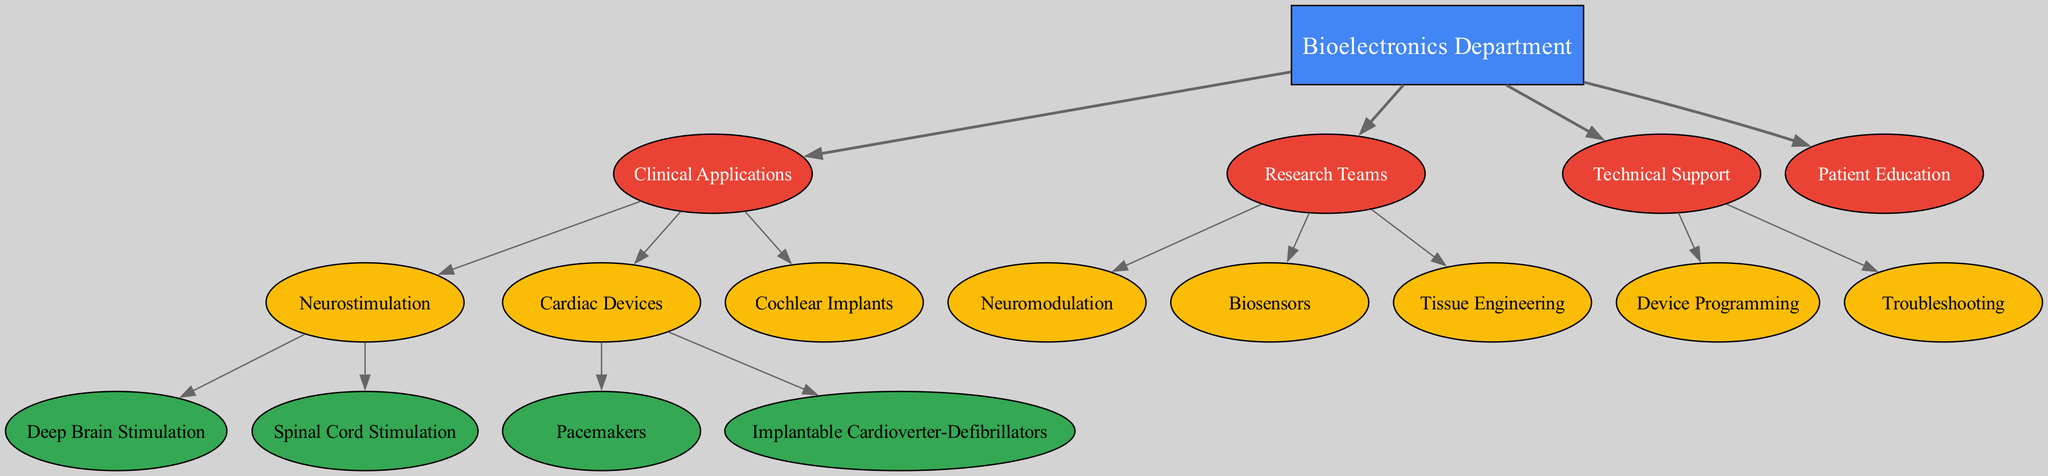What is the highest-level category in the diagram? The highest-level category in the diagram is "Bioelectronics Department," which encompasses all other specialties and teams within the structure. This can be identified as the root node of the hierarchy, indicating it is at the topmost position.
Answer: Bioelectronics Department How many main areas are there under the Bioelectronics Department? There are four main areas under the "Bioelectronics Department": Clinical Applications, Research Teams, Technical Support, and Patient Education. This can be determined by counting the first-level nodes branching directly from the main department.
Answer: 4 Which specialty includes Deep Brain Stimulation? The specialty that includes Deep Brain Stimulation is "Neurostimulation," a subcategory under "Clinical Applications." This can be found by tracing the pathway down from the Bioelectronics Department to Clinical Applications, then to Neurostimulation.
Answer: Neurostimulation What is the number of specialties listed under Clinical Applications? There are three specialties listed under "Clinical Applications": Neurostimulation, Cardiac Devices, and Cochlear Implants. This is determined by counting the distinct nodes in the Clinical Applications branch.
Answer: 3 What are the two main types of cardiac devices mentioned? The two main types of cardiac devices mentioned are "Pacemakers" and "Implantable Cardioverter-Defibrillators," both of which fall under the "Cardiac Devices" specialty. This is identified by following the branch from Clinical Applications to Cardiac Devices.
Answer: Pacemakers and Implantable Cardioverter-Defibrillators Which section does "Device Programming" belong to? "Device Programming" belongs to the "Technical Support" section. This can be verified by tracing the node name back to its parent category in the hierarchy.
Answer: Technical Support Which research team focuses on biosensors? The research team that focuses on biosensors is simply called "Biosensors." This is a straightforward identification found under the "Research Teams" section, directly associating it with this particular specialty.
Answer: Biosensors How many nodes are there under the Technical Support section? There are two nodes under the "Technical Support" section: "Device Programming" and "Troubleshooting." This number is derived by counting the distinct entities within that particular branch of the diagram.
Answer: 2 What is the relationship between "Neurostimulation" and "Biosensors" in terms of their department? Both "Neurostimulation" and "Biosensors" belong to different categories within the "Bioelectronics Department," with Neurostimulation under Clinical Applications and Biosensors under Research Teams. This indicates they operate in distinct areas but contribute to the broader focus of bioelectronics.
Answer: Different categories within Bioelectronics Department 